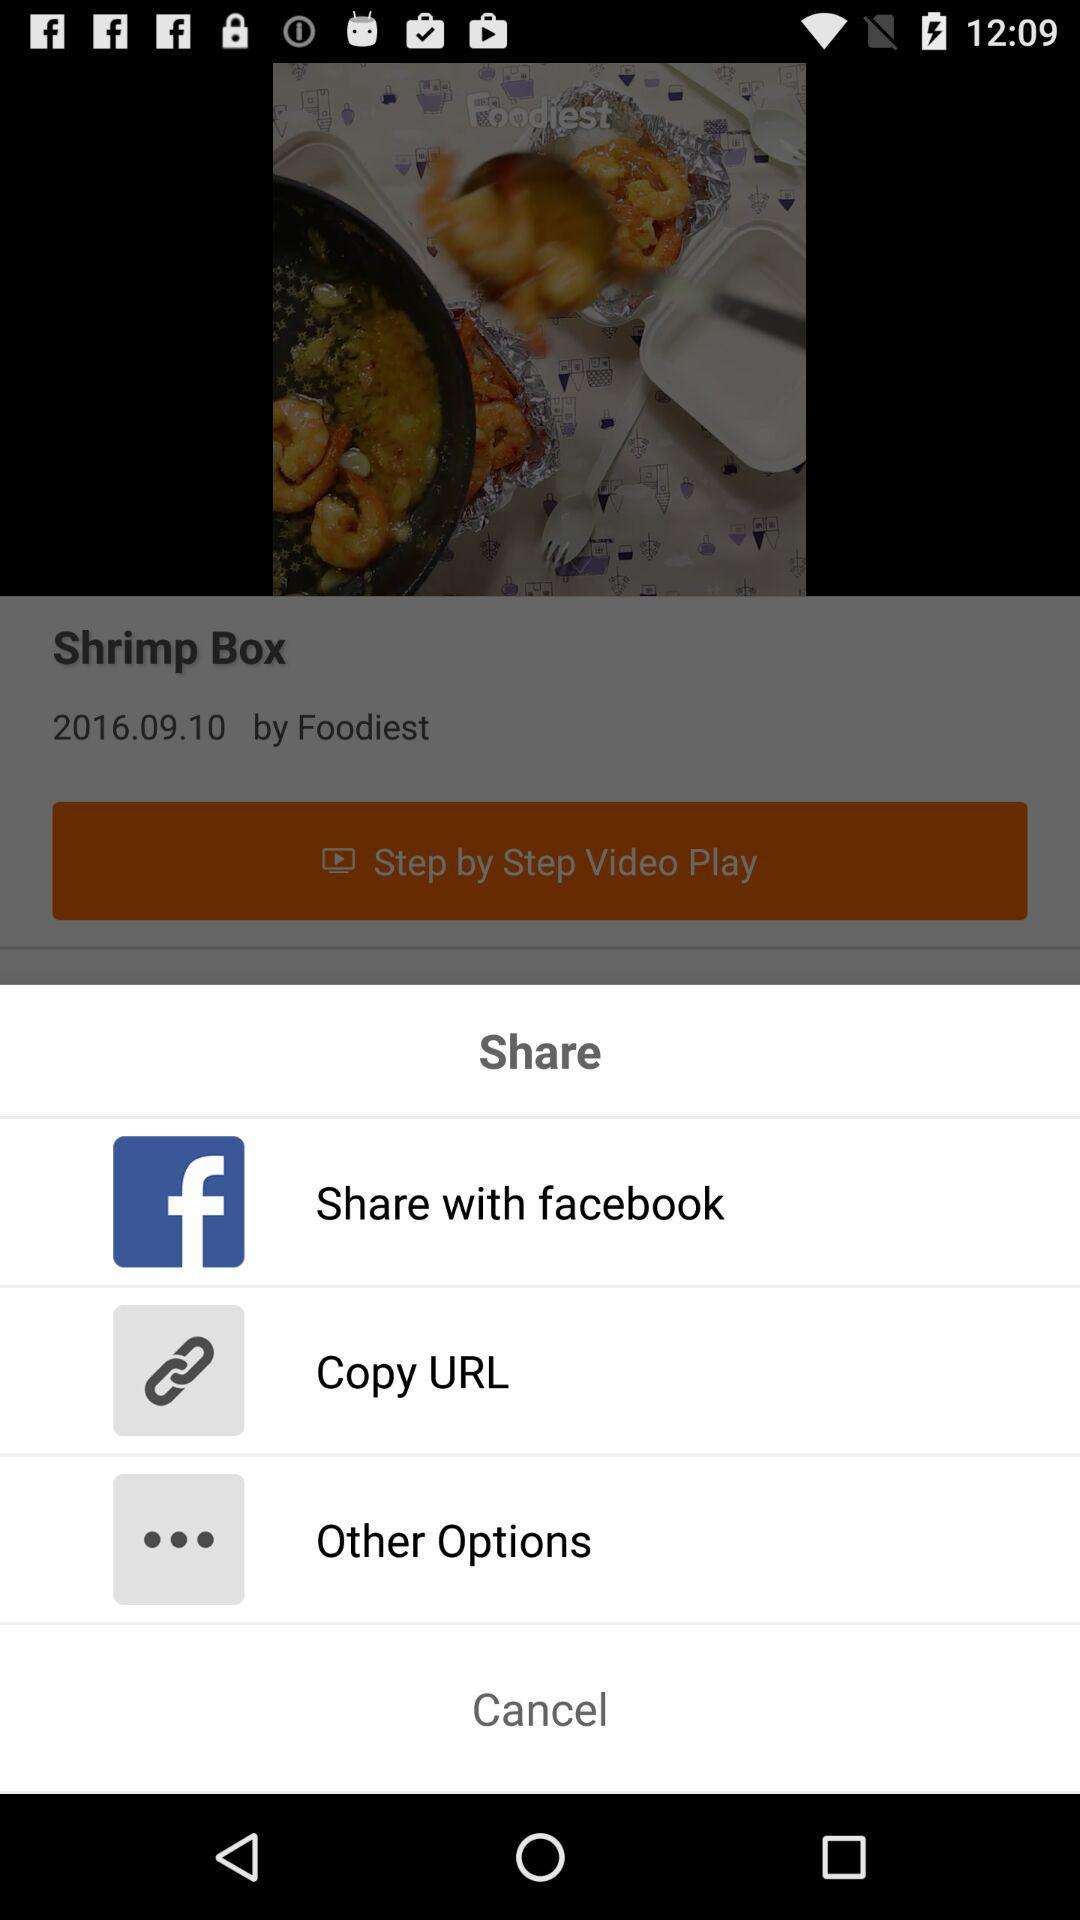What is the duration of "Shrimp Box"?
When the provided information is insufficient, respond with <no answer>. <no answer> 